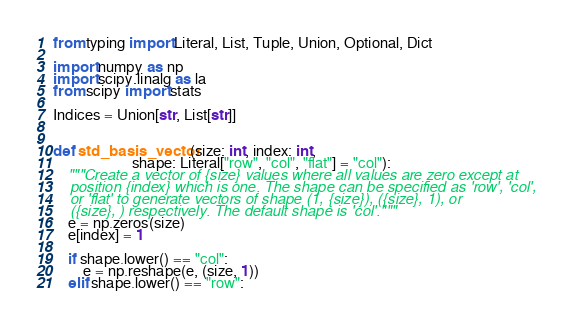Convert code to text. <code><loc_0><loc_0><loc_500><loc_500><_Python_>from typing import Literal, List, Tuple, Union, Optional, Dict

import numpy as np
import scipy.linalg as la
from scipy import stats

Indices = Union[str, List[str]]


def std_basis_vector(size: int, index: int,
                     shape: Literal["row", "col", "flat"] = "col"):
    """Create a vector of {size} values where all values are zero except at
    position {index} which is one. The shape can be specified as 'row', 'col',
    or 'flat' to generate vectors of shape (1, {size}), ({size}, 1), or
    ({size}, ) respectively. The default shape is 'col'."""
    e = np.zeros(size)
    e[index] = 1

    if shape.lower() == "col":
        e = np.reshape(e, (size, 1))
    elif shape.lower() == "row":</code> 